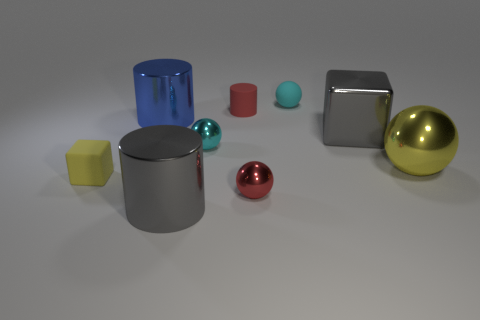Is there any other thing that is made of the same material as the tiny block?
Provide a succinct answer. Yes. What number of objects are gray things that are left of the cyan rubber sphere or yellow shiny cylinders?
Your response must be concise. 1. Are there the same number of large blue metal things that are left of the large yellow metal object and big green metal objects?
Offer a terse response. No. Do the cyan metal thing and the matte sphere have the same size?
Your answer should be compact. Yes. What is the color of the metallic block that is the same size as the gray metallic cylinder?
Offer a terse response. Gray. Do the gray cube and the red thing that is in front of the small matte block have the same size?
Your answer should be compact. No. What number of shiny blocks are the same color as the matte sphere?
Provide a short and direct response. 0. What number of things are either tiny red shiny spheres or small balls that are in front of the cyan matte thing?
Keep it short and to the point. 2. There is a metallic thing that is on the left side of the gray cylinder; is its size the same as the cube that is on the left side of the big blue shiny cylinder?
Give a very brief answer. No. Are there any cyan balls made of the same material as the tiny red ball?
Give a very brief answer. Yes. 